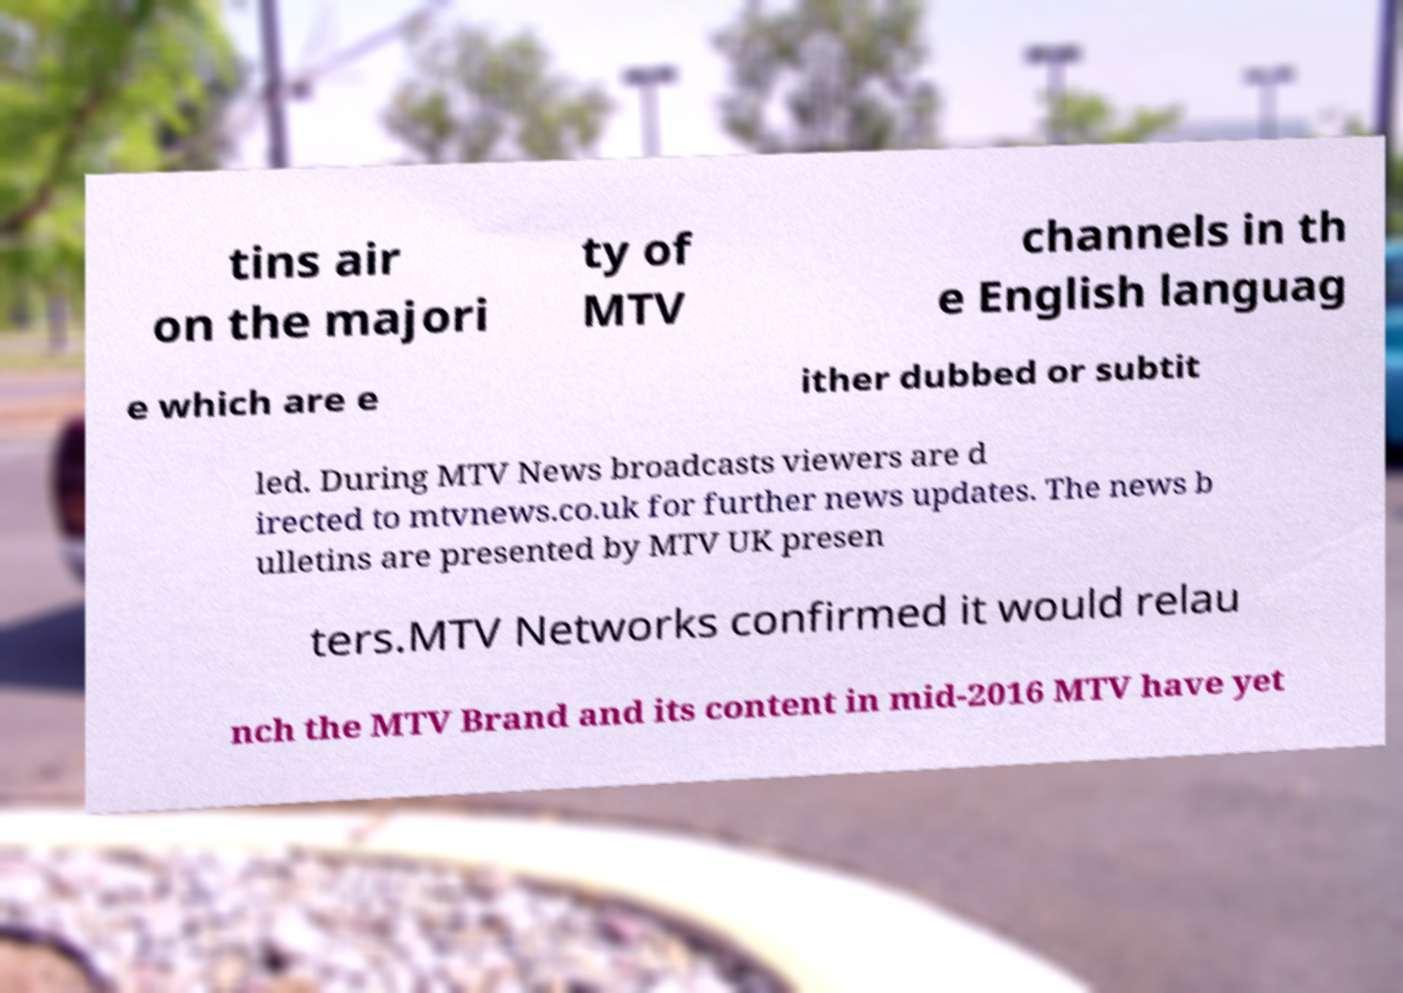Please identify and transcribe the text found in this image. tins air on the majori ty of MTV channels in th e English languag e which are e ither dubbed or subtit led. During MTV News broadcasts viewers are d irected to mtvnews.co.uk for further news updates. The news b ulletins are presented by MTV UK presen ters.MTV Networks confirmed it would relau nch the MTV Brand and its content in mid-2016 MTV have yet 